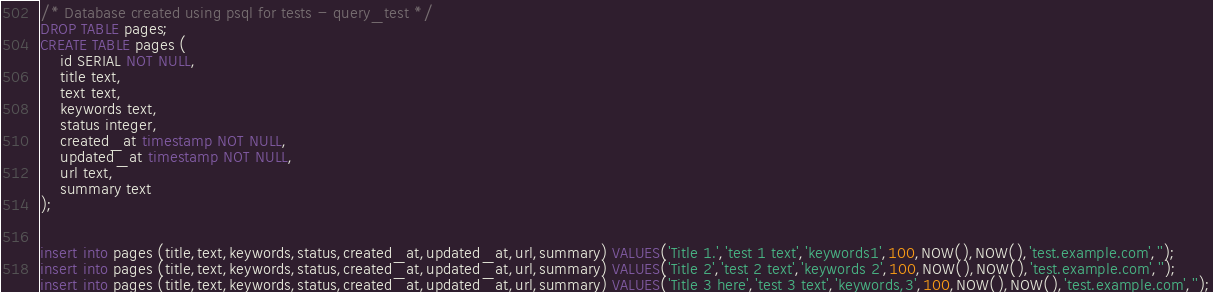<code> <loc_0><loc_0><loc_500><loc_500><_SQL_>/* Database created using psql for tests - query_test */
DROP TABLE pages;
CREATE TABLE pages (
    id SERIAL NOT NULL,
    title text,
    text text,
    keywords text,
    status integer,
    created_at timestamp NOT NULL,
    updated_at timestamp NOT NULL,
    url text,
    summary text
);


insert into pages (title,text,keywords,status,created_at,updated_at,url,summary) VALUES('Title 1.','test 1 text','keywords1',100,NOW(),NOW(),'test.example.com','');
insert into pages (title,text,keywords,status,created_at,updated_at,url,summary) VALUES('Title 2','test 2 text','keywords 2',100,NOW(),NOW(),'test.example.com','');
insert into pages (title,text,keywords,status,created_at,updated_at,url,summary) VALUES('Title 3 here','test 3 text','keywords,3',100,NOW(),NOW(),'test.example.com','');
</code> 